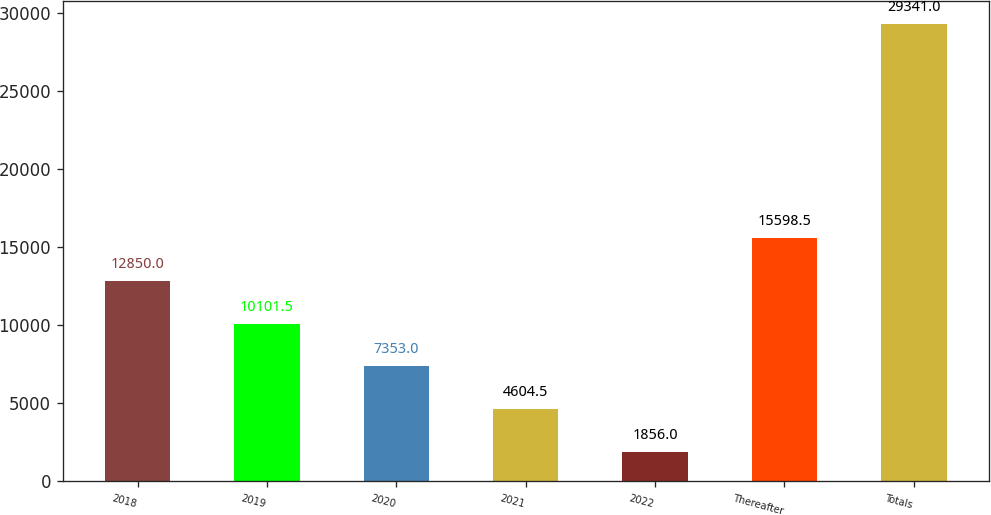Convert chart. <chart><loc_0><loc_0><loc_500><loc_500><bar_chart><fcel>2018<fcel>2019<fcel>2020<fcel>2021<fcel>2022<fcel>Thereafter<fcel>Totals<nl><fcel>12850<fcel>10101.5<fcel>7353<fcel>4604.5<fcel>1856<fcel>15598.5<fcel>29341<nl></chart> 